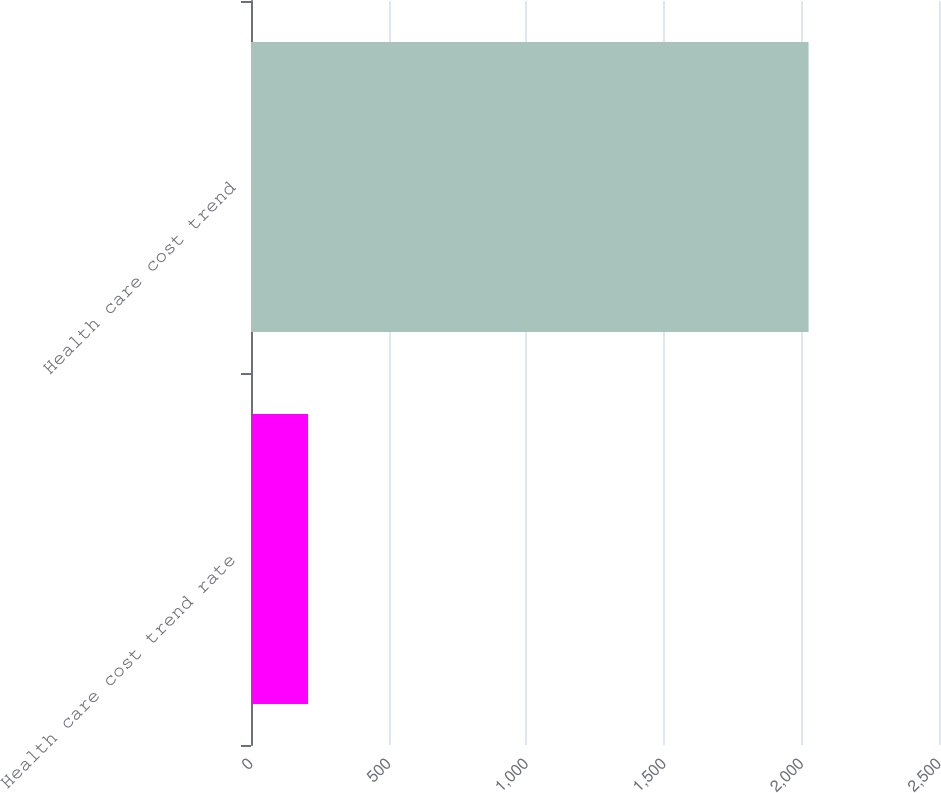<chart> <loc_0><loc_0><loc_500><loc_500><bar_chart><fcel>Health care cost trend rate<fcel>Health care cost trend<nl><fcel>207.1<fcel>2026<nl></chart> 